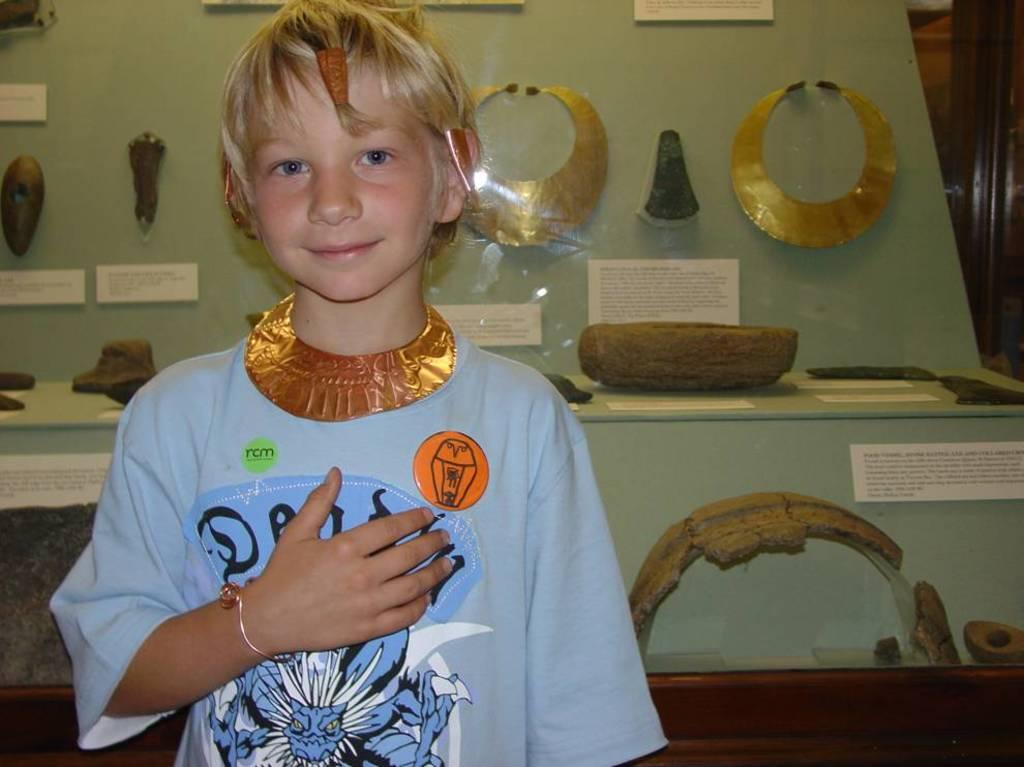What is the main subject of the image? The main subject of the image is a child. Can you describe the child's appearance? The child is wearing clothes and smiling. What can be seen in the background of the image? There are Egyptian people wearing ornaments in the background. What object is present in the image that has text on it? There is a piece of paper in the image with text on it. What type of writer is depicted in the image? There is no writer depicted in the image; it features a child and Egyptian people in the background. How many needles can be seen in the image? There are no needles present in the image. 